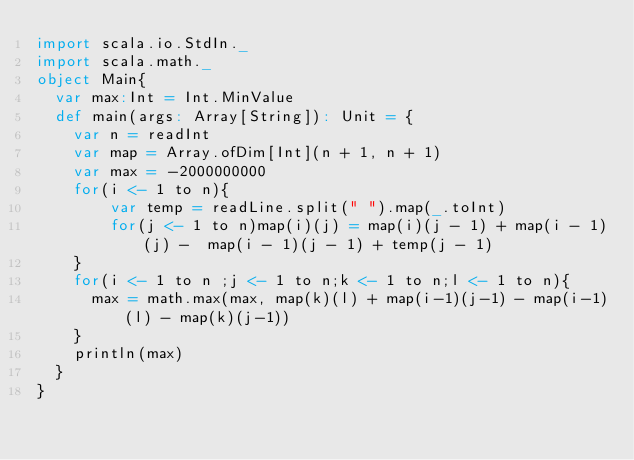<code> <loc_0><loc_0><loc_500><loc_500><_Scala_>import scala.io.StdIn._
import scala.math._
object Main{
	var max:Int = Int.MinValue
	def main(args: Array[String]): Unit = {
		var n = readInt
		var map = Array.ofDim[Int](n + 1, n + 1)
		var max = -2000000000
		for(i <- 1 to n){
			  var temp = readLine.split(" ").map(_.toInt)
		    for(j <- 1 to n)map(i)(j) = map(i)(j - 1) + map(i - 1)(j) -  map(i - 1)(j - 1) + temp(j - 1)
		}
		for(i <- 1 to n ;j <- 1 to n;k <- 1 to n;l <- 1 to n){
			max = math.max(max, map(k)(l) + map(i-1)(j-1) - map(i-1)(l) - map(k)(j-1))
		}
		println(max)
  }
}</code> 